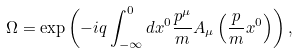Convert formula to latex. <formula><loc_0><loc_0><loc_500><loc_500>\Omega = \exp \left ( - i q \int _ { - \infty } ^ { 0 } d x ^ { 0 } \frac { p ^ { \mu } } { m } A _ { \mu } \left ( \frac { p } { m } x ^ { 0 } \right ) \right ) ,</formula> 